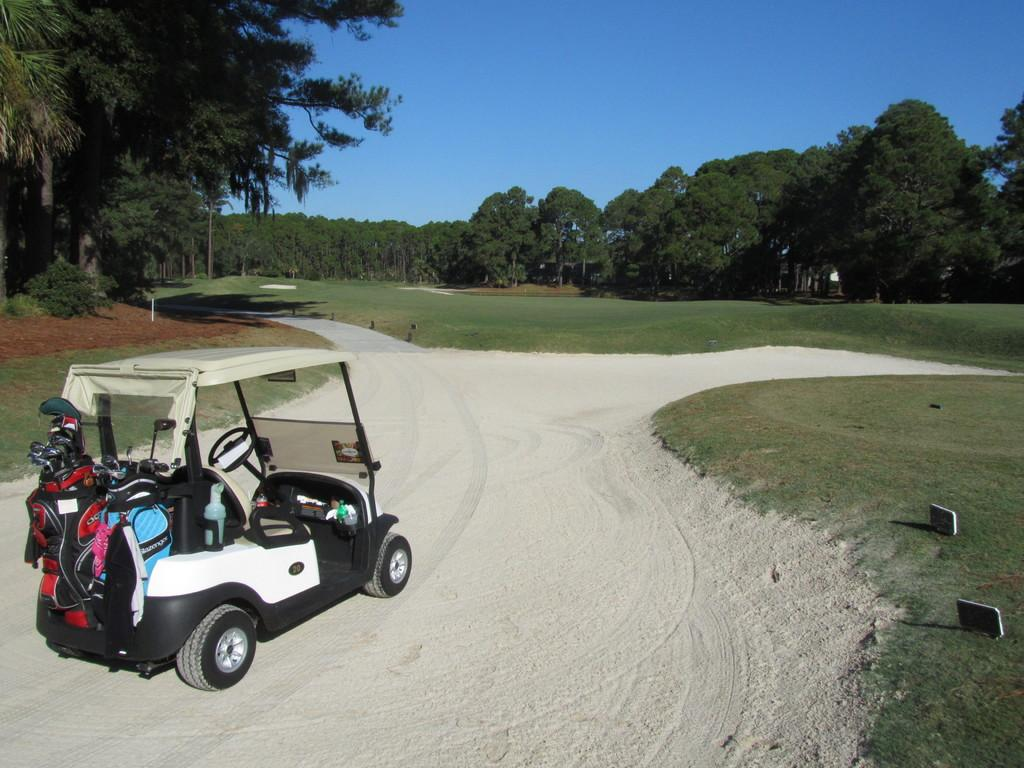What type of path is in the garden in the image? There is a sand way in the garden in the image. What is on the sand way in the image? A vehicle is present on the sand way in the image. What can be seen in the center of the image? There are trees in the center of the image. What is visible at the top of the image? The sky is visible at the top of the image. How many eggs are on the list hanging on the wall in the image? There is no list or wall present in the image; it features a sand way, a vehicle, trees, and the sky. 